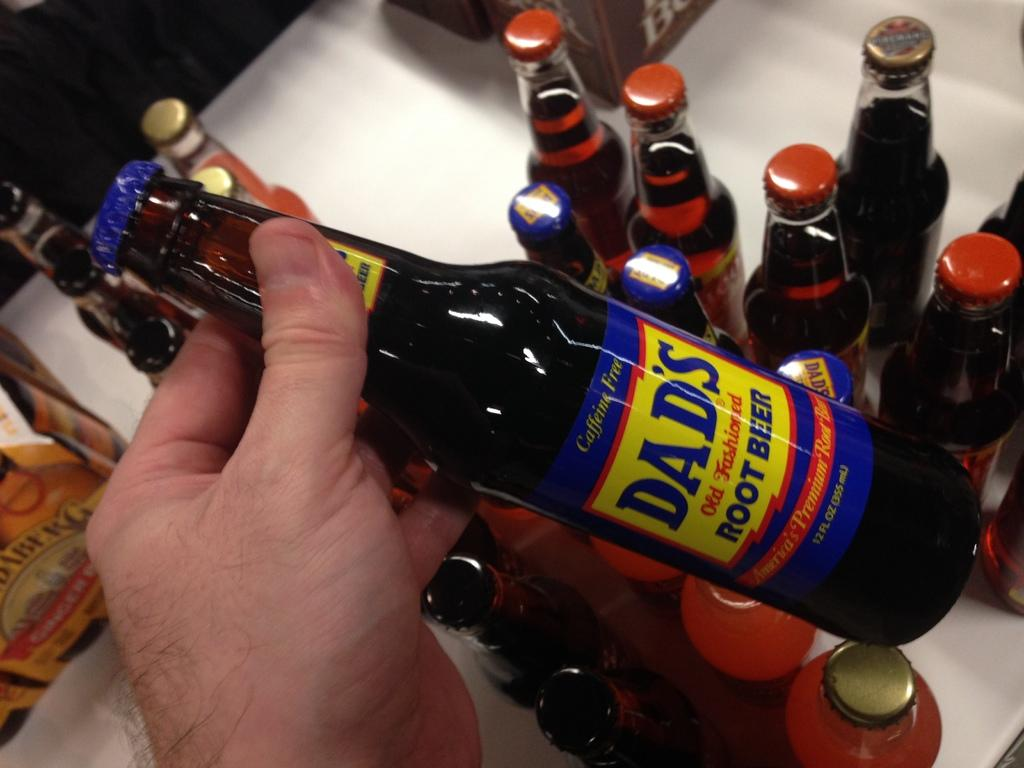Provide a one-sentence caption for the provided image. A bunch of bottles are on a table with  bottle of Dad' root beer being held up. 